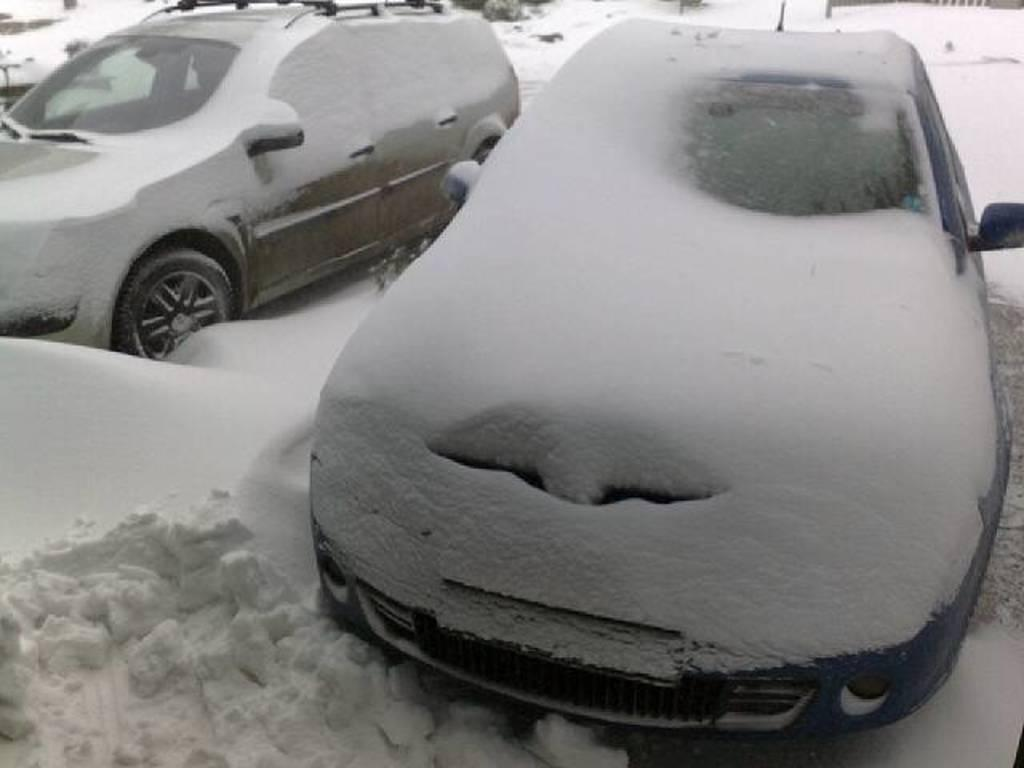What type of vehicles can be seen in the image? There are cars in the image. How are the cars affected by the weather in the image? The cars are covered with snow. What is the condition of the ground in the image? There is snow on the ground. What can be seen in the background of the image? The background of the image includes snow. Can you see a knee-high cork tied in a knot in the image? There is no knee-high cork tied in a knot present in the image. 